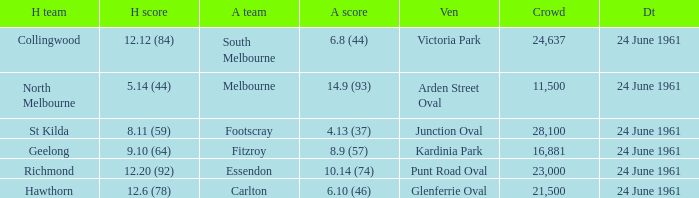What is the date of the game where the home team scored 9.10 (64)? 24 June 1961. 